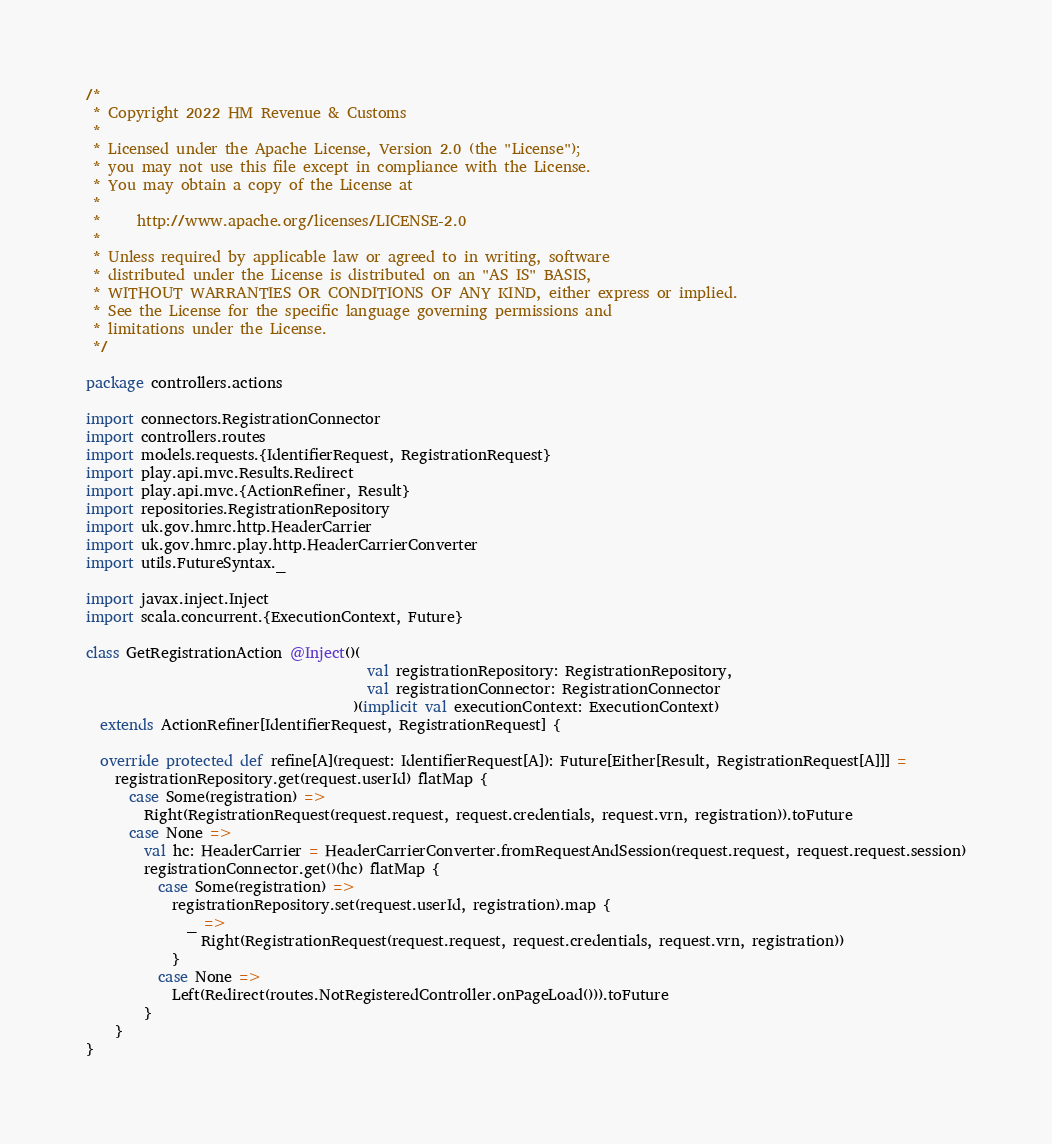<code> <loc_0><loc_0><loc_500><loc_500><_Scala_>/*
 * Copyright 2022 HM Revenue & Customs
 *
 * Licensed under the Apache License, Version 2.0 (the "License");
 * you may not use this file except in compliance with the License.
 * You may obtain a copy of the License at
 *
 *     http://www.apache.org/licenses/LICENSE-2.0
 *
 * Unless required by applicable law or agreed to in writing, software
 * distributed under the License is distributed on an "AS IS" BASIS,
 * WITHOUT WARRANTIES OR CONDITIONS OF ANY KIND, either express or implied.
 * See the License for the specific language governing permissions and
 * limitations under the License.
 */

package controllers.actions

import connectors.RegistrationConnector
import controllers.routes
import models.requests.{IdentifierRequest, RegistrationRequest}
import play.api.mvc.Results.Redirect
import play.api.mvc.{ActionRefiner, Result}
import repositories.RegistrationRepository
import uk.gov.hmrc.http.HeaderCarrier
import uk.gov.hmrc.play.http.HeaderCarrierConverter
import utils.FutureSyntax._

import javax.inject.Inject
import scala.concurrent.{ExecutionContext, Future}

class GetRegistrationAction @Inject()(
                                       val registrationRepository: RegistrationRepository,
                                       val registrationConnector: RegistrationConnector
                                     )(implicit val executionContext: ExecutionContext)
  extends ActionRefiner[IdentifierRequest, RegistrationRequest] {

  override protected def refine[A](request: IdentifierRequest[A]): Future[Either[Result, RegistrationRequest[A]]] =
    registrationRepository.get(request.userId) flatMap {
      case Some(registration) =>
        Right(RegistrationRequest(request.request, request.credentials, request.vrn, registration)).toFuture
      case None =>
        val hc: HeaderCarrier = HeaderCarrierConverter.fromRequestAndSession(request.request, request.request.session)
        registrationConnector.get()(hc) flatMap {
          case Some(registration) =>
            registrationRepository.set(request.userId, registration).map {
              _ =>
                Right(RegistrationRequest(request.request, request.credentials, request.vrn, registration))
            }
          case None =>
            Left(Redirect(routes.NotRegisteredController.onPageLoad())).toFuture
        }
    }
}</code> 